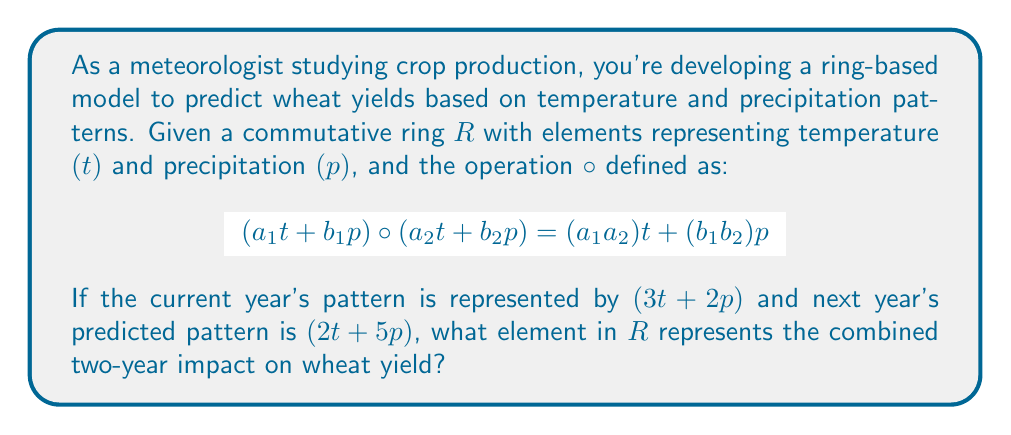Help me with this question. Let's approach this step-by-step:

1) We are working in a commutative ring $R$ with a special operation $\circ$ defined for elements of the form $at + bp$.

2) The current year's pattern is represented by $(3t + 2p)$.

3) Next year's predicted pattern is represented by $(2t + 5p)$.

4) To find the combined two-year impact, we need to apply the $\circ$ operation to these two elements.

5) Using the given definition of $\circ$:

   $$(3t + 2p) \circ (2t + 5p) = (3 \cdot 2)t + (2 \cdot 5)p$$

6) Simplifying:
   
   $$(3t + 2p) \circ (2t + 5p) = 6t + 10p$$

7) This resulting element $(6t + 10p)$ represents the combined two-year impact on wheat yield in the ring $R$.

The coefficients 6 and 10 indicate the cumulative effect of temperature and precipitation, respectively, over the two-year period on the wheat yield prediction model.
Answer: $6t + 10p$ 